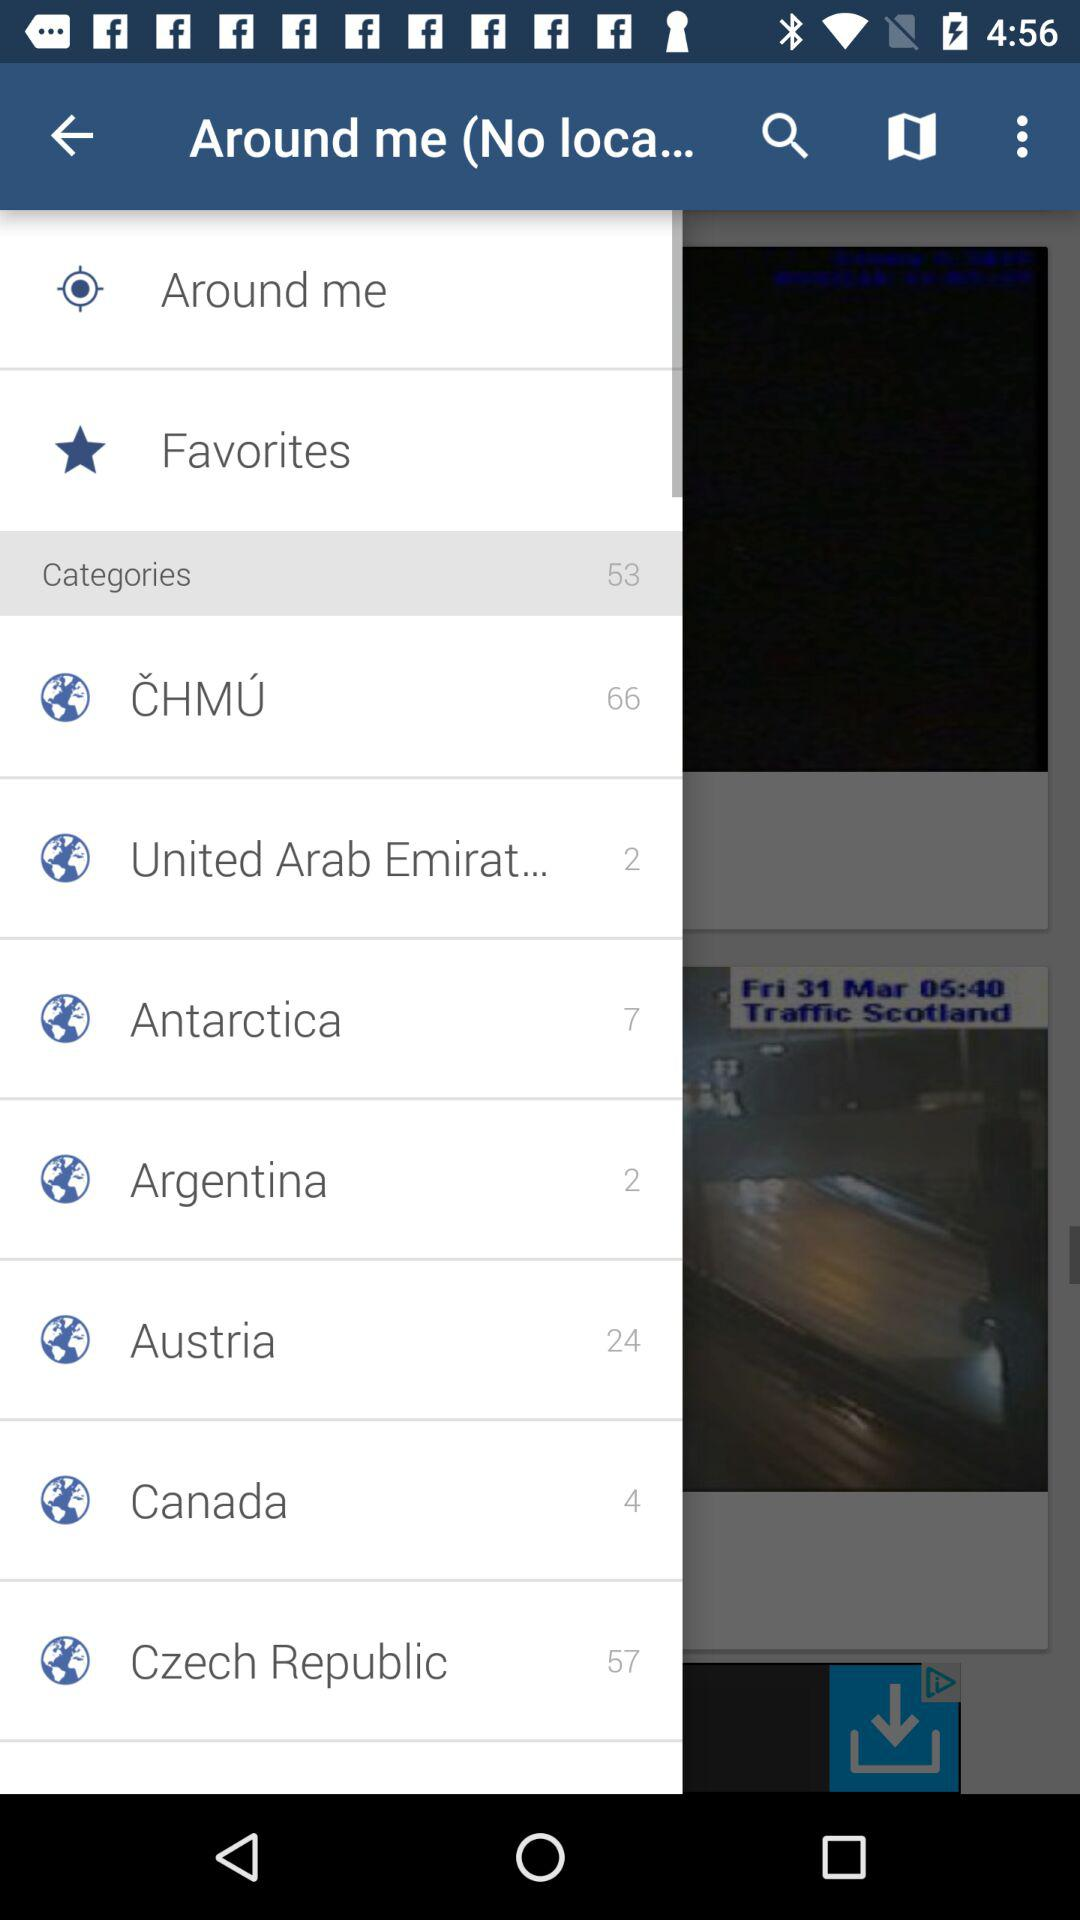How many categories are there in the United Arab Emirates? There are two categories. 